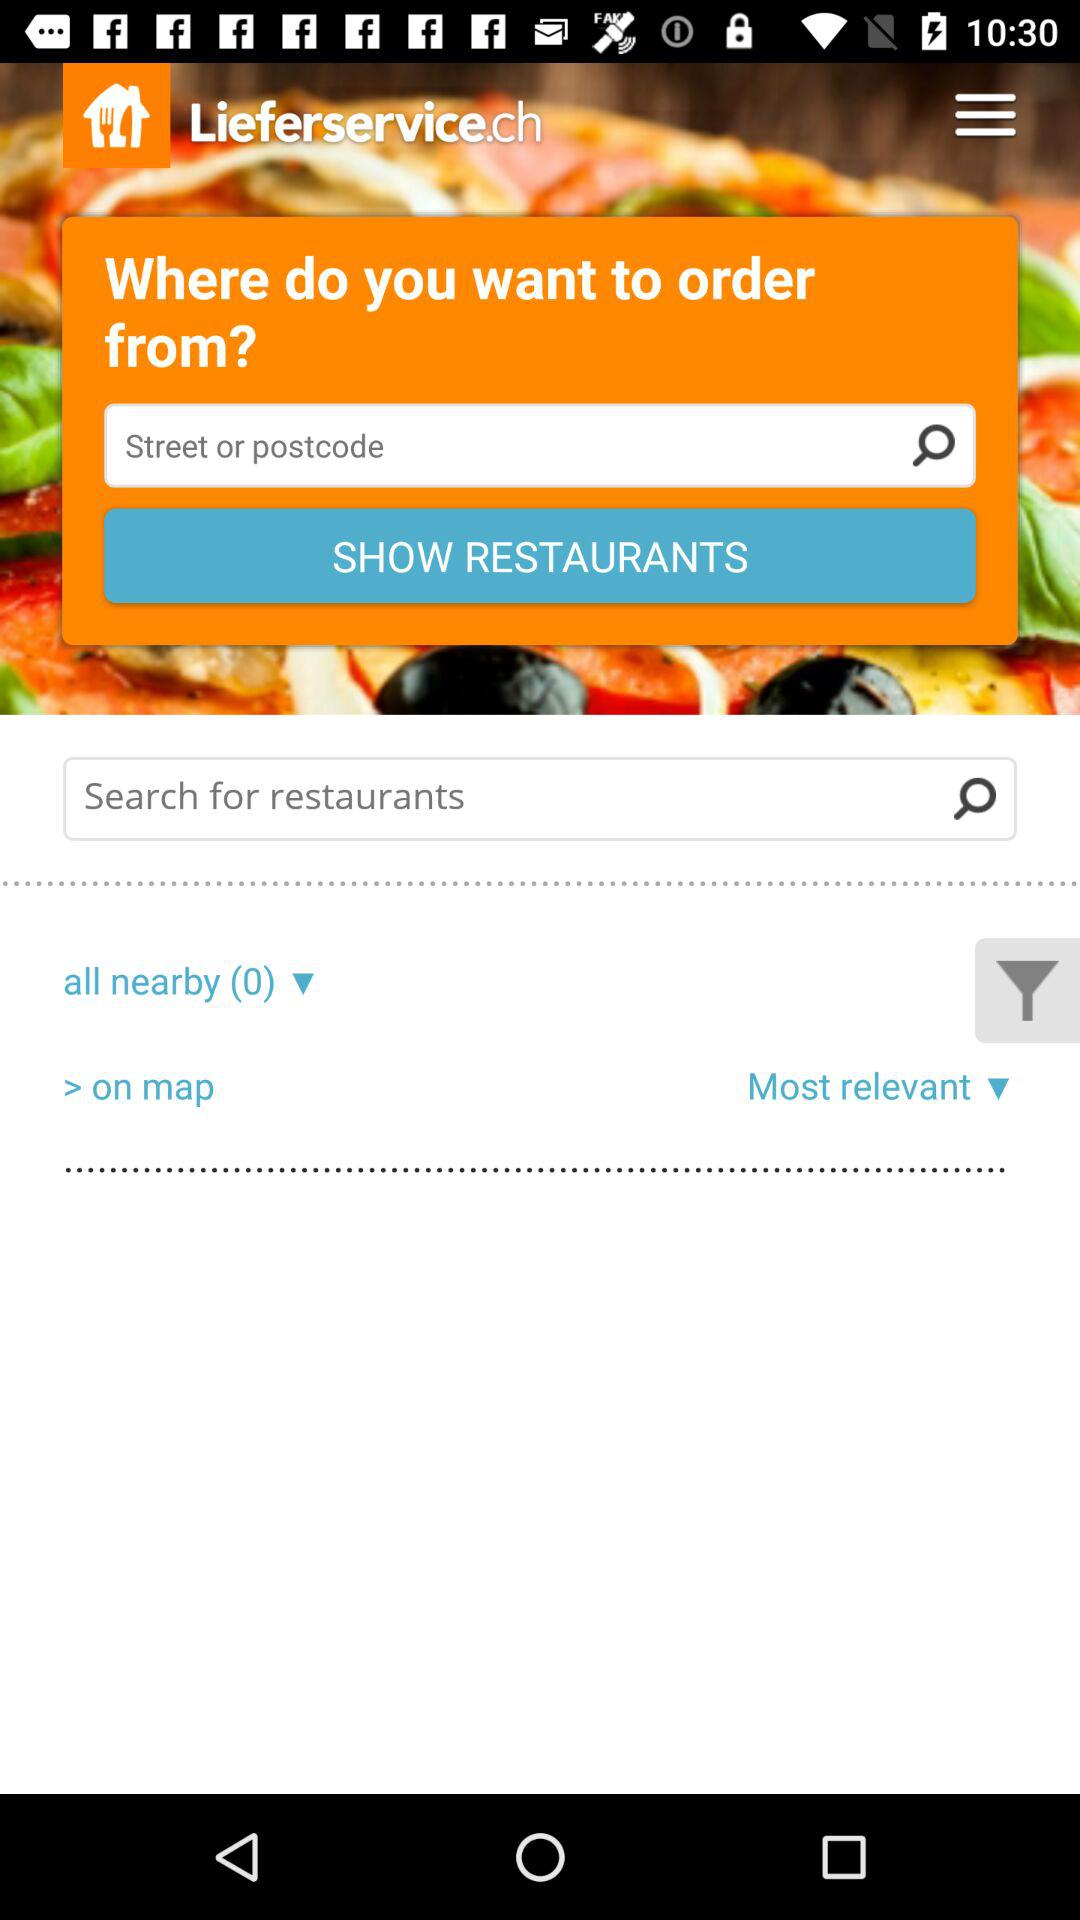How many restaurants are on the map?
Answer the question using a single word or phrase. 0 